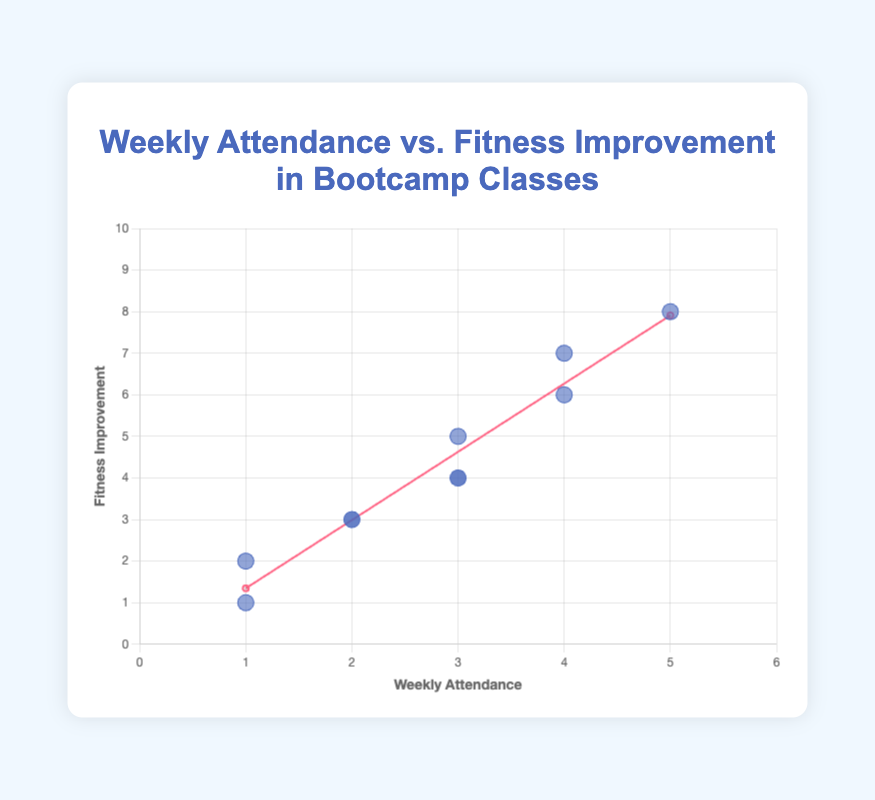What is the title of the chart? The title is typically at the top of the chart and clearly states the subject of the figure. In this case, it is "Weekly Attendance vs. Fitness Improvement in Bootcamp Classes."
Answer: Weekly Attendance vs. Fitness Improvement in Bootcamp Classes What is the range of the x-axis? The x-axis represents "Weekly Attendance" which ranges from 0 to 6 based on the axis ticks visible in the chart.
Answer: 0 to 6 Which participant has the highest fitness improvement, and what is their weekly attendance? Looking at the data points, the participant with the highest fitness improvement (8) is Laura Kennedy, who has a weekly attendance of 5.
Answer: Laura Kennedy, 5 Compare the fitness improvement for participants with the same weekly attendance. There are three participants with a weekly attendance of 3: James Ryan (fitness improvement 4), Anna Byrne (fitness improvement 5), and Niamh O'Sullivan (fitness improvement 4). Anna Byrne has the highest fitness improvement among them.
Answer: Anna Byrne What does the trend line indicate about the relationship between weekly attendance and fitness improvement? The trend line shows a positive slope, implying that, generally, as weekly attendance increases, fitness improvement also increases. This relationship is supported by the upward direction of the trend line connecting lower to higher weekly attendance values.
Answer: Positive correlation How many participants attended the bootcamp classes for exactly 2 weeks? The dots representing participants who attended for exactly 2 weeks are observed at the x-value of 2, with two such data points visible.
Answer: 2 participants What is the average fitness improvement for participants who attended 4 classes per week? The participants who attended 4 classes per week are Emma Walsh (6) and Michael Kelly (7). The average is calculated as (6 + 7) / 2, which equals 6.5.
Answer: 6.5 Is there any participant with a fitness improvement of 5, and what is their weekly attendance? By examining the data points, Anna Byrne is the participant with a fitness improvement of 5 and she has a weekly attendance of 3.
Answer: Anna Byrne, 3 Who has a lower fitness improvement: John Murphy or Paul Doyle? Looking at the dots corresponding to these participants, John Murphy has a fitness improvement of 2, and Paul Doyle has a fitness improvement of 1. Paul Doyle has the lower fitness improvement.
Answer: Paul Doyle Are there any outliers in the scatter plot, and if so, who are they? Outliers are points that deviate significantly from other observations. No data points seem extremely inconsistent with the trend line or others in this dataset, so there are no obvious outliers.
Answer: No outliers 